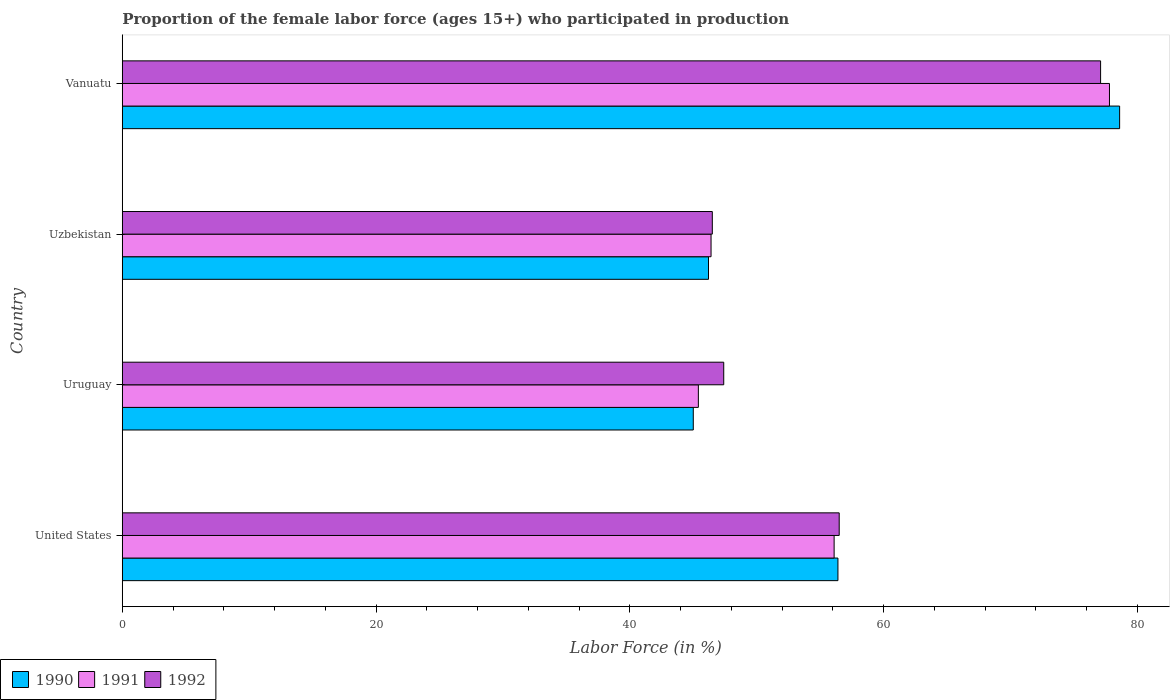Are the number of bars on each tick of the Y-axis equal?
Offer a very short reply. Yes. How many bars are there on the 2nd tick from the top?
Keep it short and to the point. 3. What is the label of the 4th group of bars from the top?
Keep it short and to the point. United States. What is the proportion of the female labor force who participated in production in 1991 in United States?
Keep it short and to the point. 56.1. Across all countries, what is the maximum proportion of the female labor force who participated in production in 1990?
Give a very brief answer. 78.6. Across all countries, what is the minimum proportion of the female labor force who participated in production in 1991?
Offer a terse response. 45.4. In which country was the proportion of the female labor force who participated in production in 1991 maximum?
Keep it short and to the point. Vanuatu. In which country was the proportion of the female labor force who participated in production in 1992 minimum?
Make the answer very short. Uzbekistan. What is the total proportion of the female labor force who participated in production in 1990 in the graph?
Offer a terse response. 226.2. What is the difference between the proportion of the female labor force who participated in production in 1990 in United States and that in Vanuatu?
Provide a short and direct response. -22.2. What is the difference between the proportion of the female labor force who participated in production in 1992 in Uzbekistan and the proportion of the female labor force who participated in production in 1991 in Vanuatu?
Ensure brevity in your answer.  -31.3. What is the average proportion of the female labor force who participated in production in 1992 per country?
Your answer should be very brief. 56.87. What is the difference between the proportion of the female labor force who participated in production in 1992 and proportion of the female labor force who participated in production in 1991 in United States?
Give a very brief answer. 0.4. In how many countries, is the proportion of the female labor force who participated in production in 1991 greater than 52 %?
Offer a terse response. 2. What is the ratio of the proportion of the female labor force who participated in production in 1992 in Uruguay to that in Vanuatu?
Give a very brief answer. 0.61. Is the difference between the proportion of the female labor force who participated in production in 1992 in United States and Uruguay greater than the difference between the proportion of the female labor force who participated in production in 1991 in United States and Uruguay?
Offer a terse response. No. What is the difference between the highest and the second highest proportion of the female labor force who participated in production in 1991?
Ensure brevity in your answer.  21.7. What is the difference between the highest and the lowest proportion of the female labor force who participated in production in 1992?
Provide a short and direct response. 30.6. In how many countries, is the proportion of the female labor force who participated in production in 1991 greater than the average proportion of the female labor force who participated in production in 1991 taken over all countries?
Provide a succinct answer. 1. Is the sum of the proportion of the female labor force who participated in production in 1991 in United States and Uruguay greater than the maximum proportion of the female labor force who participated in production in 1992 across all countries?
Keep it short and to the point. Yes. What does the 2nd bar from the bottom in Uruguay represents?
Provide a succinct answer. 1991. Are all the bars in the graph horizontal?
Make the answer very short. Yes. How many countries are there in the graph?
Keep it short and to the point. 4. Does the graph contain grids?
Give a very brief answer. No. What is the title of the graph?
Offer a very short reply. Proportion of the female labor force (ages 15+) who participated in production. What is the label or title of the X-axis?
Offer a terse response. Labor Force (in %). What is the Labor Force (in %) in 1990 in United States?
Give a very brief answer. 56.4. What is the Labor Force (in %) of 1991 in United States?
Your answer should be compact. 56.1. What is the Labor Force (in %) of 1992 in United States?
Your answer should be very brief. 56.5. What is the Labor Force (in %) of 1991 in Uruguay?
Your response must be concise. 45.4. What is the Labor Force (in %) in 1992 in Uruguay?
Provide a short and direct response. 47.4. What is the Labor Force (in %) of 1990 in Uzbekistan?
Make the answer very short. 46.2. What is the Labor Force (in %) of 1991 in Uzbekistan?
Your response must be concise. 46.4. What is the Labor Force (in %) of 1992 in Uzbekistan?
Give a very brief answer. 46.5. What is the Labor Force (in %) in 1990 in Vanuatu?
Offer a terse response. 78.6. What is the Labor Force (in %) in 1991 in Vanuatu?
Your response must be concise. 77.8. What is the Labor Force (in %) of 1992 in Vanuatu?
Make the answer very short. 77.1. Across all countries, what is the maximum Labor Force (in %) in 1990?
Provide a short and direct response. 78.6. Across all countries, what is the maximum Labor Force (in %) in 1991?
Your response must be concise. 77.8. Across all countries, what is the maximum Labor Force (in %) of 1992?
Your response must be concise. 77.1. Across all countries, what is the minimum Labor Force (in %) in 1991?
Your response must be concise. 45.4. Across all countries, what is the minimum Labor Force (in %) of 1992?
Your response must be concise. 46.5. What is the total Labor Force (in %) in 1990 in the graph?
Keep it short and to the point. 226.2. What is the total Labor Force (in %) in 1991 in the graph?
Provide a short and direct response. 225.7. What is the total Labor Force (in %) of 1992 in the graph?
Offer a very short reply. 227.5. What is the difference between the Labor Force (in %) in 1991 in United States and that in Uruguay?
Provide a short and direct response. 10.7. What is the difference between the Labor Force (in %) of 1992 in United States and that in Uruguay?
Ensure brevity in your answer.  9.1. What is the difference between the Labor Force (in %) in 1990 in United States and that in Uzbekistan?
Provide a short and direct response. 10.2. What is the difference between the Labor Force (in %) of 1990 in United States and that in Vanuatu?
Keep it short and to the point. -22.2. What is the difference between the Labor Force (in %) in 1991 in United States and that in Vanuatu?
Provide a succinct answer. -21.7. What is the difference between the Labor Force (in %) in 1992 in United States and that in Vanuatu?
Your answer should be compact. -20.6. What is the difference between the Labor Force (in %) of 1990 in Uruguay and that in Uzbekistan?
Your response must be concise. -1.2. What is the difference between the Labor Force (in %) of 1990 in Uruguay and that in Vanuatu?
Ensure brevity in your answer.  -33.6. What is the difference between the Labor Force (in %) of 1991 in Uruguay and that in Vanuatu?
Offer a terse response. -32.4. What is the difference between the Labor Force (in %) of 1992 in Uruguay and that in Vanuatu?
Make the answer very short. -29.7. What is the difference between the Labor Force (in %) in 1990 in Uzbekistan and that in Vanuatu?
Your response must be concise. -32.4. What is the difference between the Labor Force (in %) of 1991 in Uzbekistan and that in Vanuatu?
Your answer should be very brief. -31.4. What is the difference between the Labor Force (in %) in 1992 in Uzbekistan and that in Vanuatu?
Provide a succinct answer. -30.6. What is the difference between the Labor Force (in %) in 1990 in United States and the Labor Force (in %) in 1991 in Uruguay?
Make the answer very short. 11. What is the difference between the Labor Force (in %) in 1991 in United States and the Labor Force (in %) in 1992 in Uruguay?
Provide a succinct answer. 8.7. What is the difference between the Labor Force (in %) of 1990 in United States and the Labor Force (in %) of 1991 in Uzbekistan?
Your response must be concise. 10. What is the difference between the Labor Force (in %) of 1991 in United States and the Labor Force (in %) of 1992 in Uzbekistan?
Provide a short and direct response. 9.6. What is the difference between the Labor Force (in %) in 1990 in United States and the Labor Force (in %) in 1991 in Vanuatu?
Provide a succinct answer. -21.4. What is the difference between the Labor Force (in %) in 1990 in United States and the Labor Force (in %) in 1992 in Vanuatu?
Offer a terse response. -20.7. What is the difference between the Labor Force (in %) in 1991 in United States and the Labor Force (in %) in 1992 in Vanuatu?
Make the answer very short. -21. What is the difference between the Labor Force (in %) in 1990 in Uruguay and the Labor Force (in %) in 1991 in Uzbekistan?
Keep it short and to the point. -1.4. What is the difference between the Labor Force (in %) in 1990 in Uruguay and the Labor Force (in %) in 1991 in Vanuatu?
Your answer should be compact. -32.8. What is the difference between the Labor Force (in %) of 1990 in Uruguay and the Labor Force (in %) of 1992 in Vanuatu?
Your response must be concise. -32.1. What is the difference between the Labor Force (in %) of 1991 in Uruguay and the Labor Force (in %) of 1992 in Vanuatu?
Keep it short and to the point. -31.7. What is the difference between the Labor Force (in %) of 1990 in Uzbekistan and the Labor Force (in %) of 1991 in Vanuatu?
Make the answer very short. -31.6. What is the difference between the Labor Force (in %) in 1990 in Uzbekistan and the Labor Force (in %) in 1992 in Vanuatu?
Keep it short and to the point. -30.9. What is the difference between the Labor Force (in %) of 1991 in Uzbekistan and the Labor Force (in %) of 1992 in Vanuatu?
Provide a short and direct response. -30.7. What is the average Labor Force (in %) in 1990 per country?
Your answer should be compact. 56.55. What is the average Labor Force (in %) in 1991 per country?
Give a very brief answer. 56.42. What is the average Labor Force (in %) in 1992 per country?
Offer a terse response. 56.88. What is the difference between the Labor Force (in %) of 1990 and Labor Force (in %) of 1991 in United States?
Your answer should be very brief. 0.3. What is the difference between the Labor Force (in %) in 1991 and Labor Force (in %) in 1992 in United States?
Your answer should be compact. -0.4. What is the difference between the Labor Force (in %) of 1990 and Labor Force (in %) of 1992 in Uruguay?
Ensure brevity in your answer.  -2.4. What is the difference between the Labor Force (in %) in 1991 and Labor Force (in %) in 1992 in Uruguay?
Your answer should be very brief. -2. What is the difference between the Labor Force (in %) of 1990 and Labor Force (in %) of 1991 in Uzbekistan?
Provide a short and direct response. -0.2. What is the difference between the Labor Force (in %) of 1991 and Labor Force (in %) of 1992 in Uzbekistan?
Provide a succinct answer. -0.1. What is the difference between the Labor Force (in %) in 1990 and Labor Force (in %) in 1992 in Vanuatu?
Provide a succinct answer. 1.5. What is the difference between the Labor Force (in %) in 1991 and Labor Force (in %) in 1992 in Vanuatu?
Your response must be concise. 0.7. What is the ratio of the Labor Force (in %) in 1990 in United States to that in Uruguay?
Make the answer very short. 1.25. What is the ratio of the Labor Force (in %) in 1991 in United States to that in Uruguay?
Offer a terse response. 1.24. What is the ratio of the Labor Force (in %) of 1992 in United States to that in Uruguay?
Provide a succinct answer. 1.19. What is the ratio of the Labor Force (in %) of 1990 in United States to that in Uzbekistan?
Give a very brief answer. 1.22. What is the ratio of the Labor Force (in %) of 1991 in United States to that in Uzbekistan?
Give a very brief answer. 1.21. What is the ratio of the Labor Force (in %) in 1992 in United States to that in Uzbekistan?
Provide a succinct answer. 1.22. What is the ratio of the Labor Force (in %) of 1990 in United States to that in Vanuatu?
Provide a succinct answer. 0.72. What is the ratio of the Labor Force (in %) in 1991 in United States to that in Vanuatu?
Provide a succinct answer. 0.72. What is the ratio of the Labor Force (in %) in 1992 in United States to that in Vanuatu?
Make the answer very short. 0.73. What is the ratio of the Labor Force (in %) of 1991 in Uruguay to that in Uzbekistan?
Give a very brief answer. 0.98. What is the ratio of the Labor Force (in %) in 1992 in Uruguay to that in Uzbekistan?
Your response must be concise. 1.02. What is the ratio of the Labor Force (in %) of 1990 in Uruguay to that in Vanuatu?
Provide a short and direct response. 0.57. What is the ratio of the Labor Force (in %) of 1991 in Uruguay to that in Vanuatu?
Your answer should be compact. 0.58. What is the ratio of the Labor Force (in %) of 1992 in Uruguay to that in Vanuatu?
Your answer should be compact. 0.61. What is the ratio of the Labor Force (in %) of 1990 in Uzbekistan to that in Vanuatu?
Ensure brevity in your answer.  0.59. What is the ratio of the Labor Force (in %) of 1991 in Uzbekistan to that in Vanuatu?
Ensure brevity in your answer.  0.6. What is the ratio of the Labor Force (in %) in 1992 in Uzbekistan to that in Vanuatu?
Give a very brief answer. 0.6. What is the difference between the highest and the second highest Labor Force (in %) in 1990?
Offer a terse response. 22.2. What is the difference between the highest and the second highest Labor Force (in %) of 1991?
Your response must be concise. 21.7. What is the difference between the highest and the second highest Labor Force (in %) of 1992?
Your response must be concise. 20.6. What is the difference between the highest and the lowest Labor Force (in %) of 1990?
Offer a terse response. 33.6. What is the difference between the highest and the lowest Labor Force (in %) of 1991?
Give a very brief answer. 32.4. What is the difference between the highest and the lowest Labor Force (in %) in 1992?
Provide a succinct answer. 30.6. 